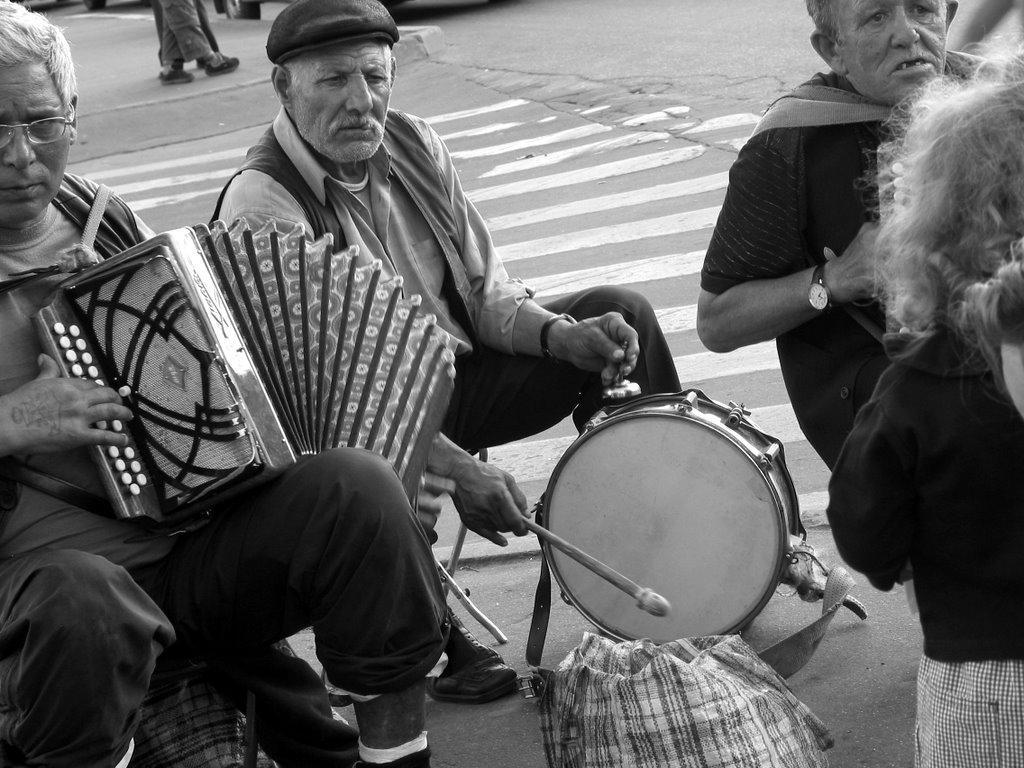What is the color scheme of the image? The image is black and white. What can be seen in the image? There are people in the image, and some of them are holding musical instruments. What object is present in the image that might be used for carrying items? There is a bag in the image. What can be seen in the background of the image? There is a road visible in the background. How many airplanes are flying over the people in the image? There are no airplanes visible in the image. What type of trucks can be seen transporting the musical instruments in the image? There are no trucks present in the image; the people are holding the musical instruments. 